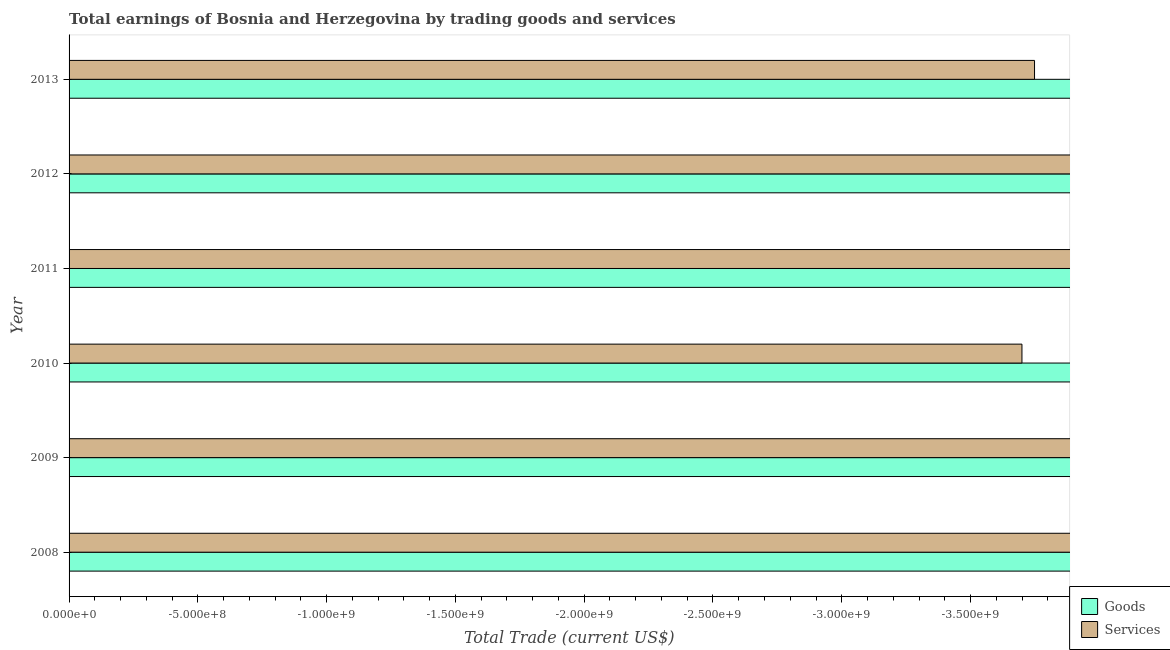How many different coloured bars are there?
Ensure brevity in your answer.  0. How many bars are there on the 4th tick from the top?
Your response must be concise. 0. What is the amount earned by trading services in 2008?
Keep it short and to the point. 0. In how many years, is the amount earned by trading services greater than -1200000000 US$?
Offer a terse response. 0. In how many years, is the amount earned by trading goods greater than the average amount earned by trading goods taken over all years?
Give a very brief answer. 0. How many bars are there?
Your answer should be very brief. 0. Are all the bars in the graph horizontal?
Your answer should be very brief. Yes. How many years are there in the graph?
Ensure brevity in your answer.  6. Are the values on the major ticks of X-axis written in scientific E-notation?
Offer a very short reply. Yes. Where does the legend appear in the graph?
Make the answer very short. Bottom right. How many legend labels are there?
Make the answer very short. 2. How are the legend labels stacked?
Offer a very short reply. Vertical. What is the title of the graph?
Ensure brevity in your answer.  Total earnings of Bosnia and Herzegovina by trading goods and services. What is the label or title of the X-axis?
Keep it short and to the point. Total Trade (current US$). What is the Total Trade (current US$) of Services in 2008?
Your answer should be compact. 0. What is the Total Trade (current US$) of Goods in 2009?
Offer a very short reply. 0. What is the Total Trade (current US$) of Services in 2009?
Your response must be concise. 0. What is the Total Trade (current US$) in Services in 2011?
Your answer should be compact. 0. What is the Total Trade (current US$) of Goods in 2012?
Your answer should be very brief. 0. What is the total Total Trade (current US$) in Goods in the graph?
Make the answer very short. 0. 